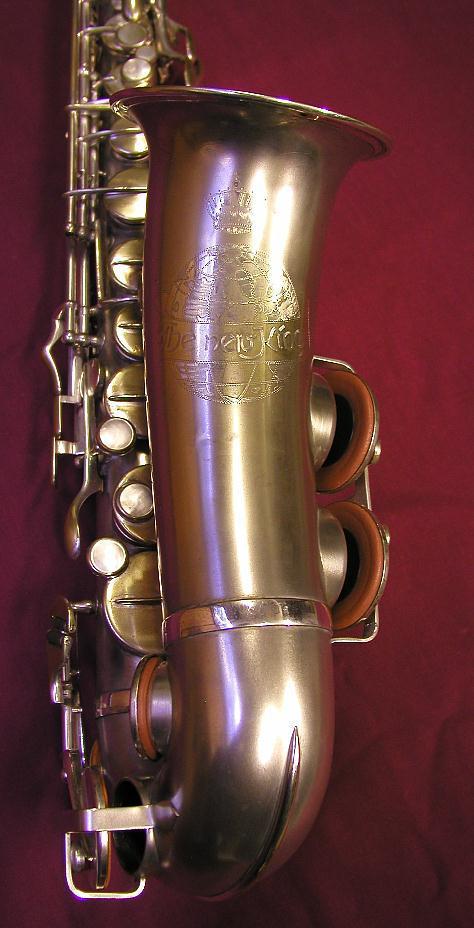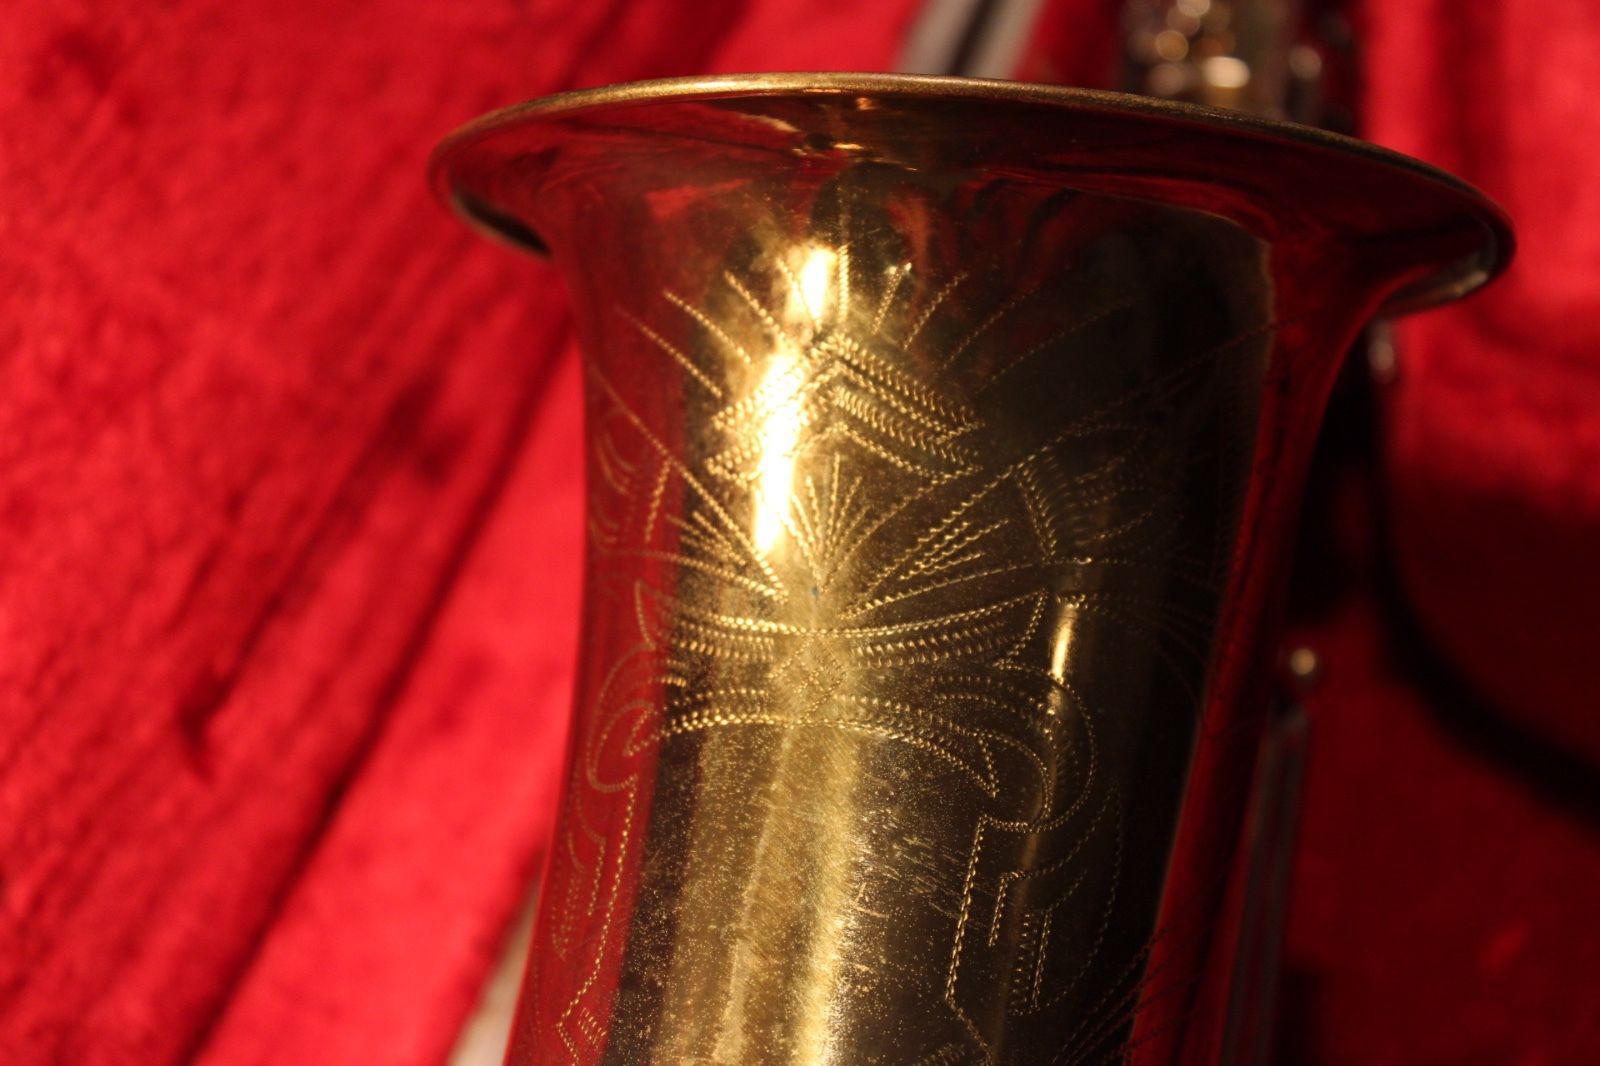The first image is the image on the left, the second image is the image on the right. For the images displayed, is the sentence "The mouthpiece of a saxophone in one image arcs in a curve and then straightens so that it is perpendicular to the instrument body." factually correct? Answer yes or no. No. The first image is the image on the left, the second image is the image on the right. Given the left and right images, does the statement "Right image shows a saxophone with a decorative etching on the exterior of its bell end." hold true? Answer yes or no. Yes. 